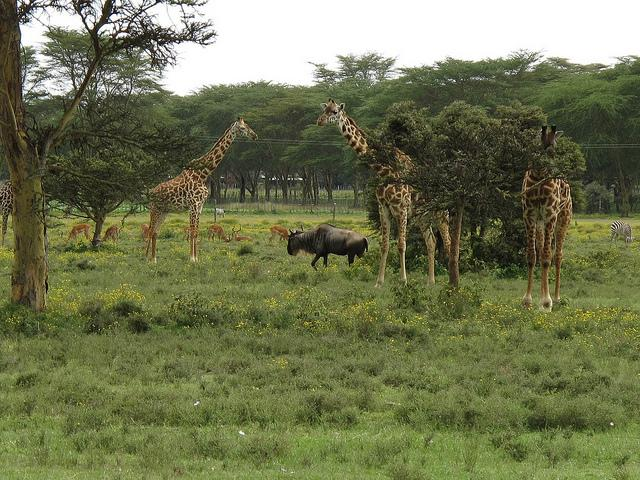How many distinct species of animals are in the field?

Choices:
A) two
B) four
C) three
D) five four 